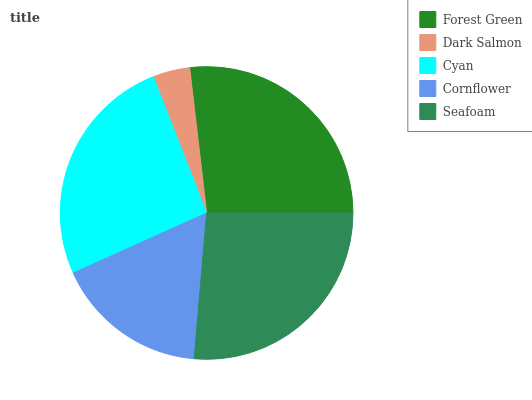Is Dark Salmon the minimum?
Answer yes or no. Yes. Is Forest Green the maximum?
Answer yes or no. Yes. Is Cyan the minimum?
Answer yes or no. No. Is Cyan the maximum?
Answer yes or no. No. Is Cyan greater than Dark Salmon?
Answer yes or no. Yes. Is Dark Salmon less than Cyan?
Answer yes or no. Yes. Is Dark Salmon greater than Cyan?
Answer yes or no. No. Is Cyan less than Dark Salmon?
Answer yes or no. No. Is Cyan the high median?
Answer yes or no. Yes. Is Cyan the low median?
Answer yes or no. Yes. Is Cornflower the high median?
Answer yes or no. No. Is Dark Salmon the low median?
Answer yes or no. No. 